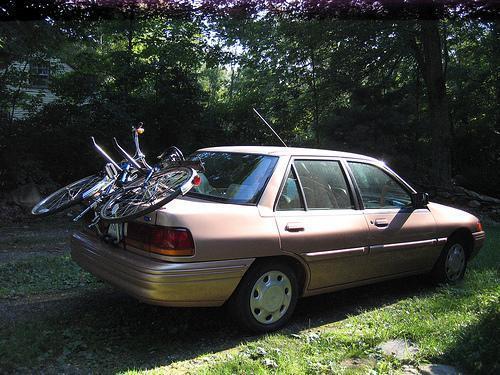How many doors does the car have?
Give a very brief answer. 4. How many bikes are on the car?
Give a very brief answer. 2. 